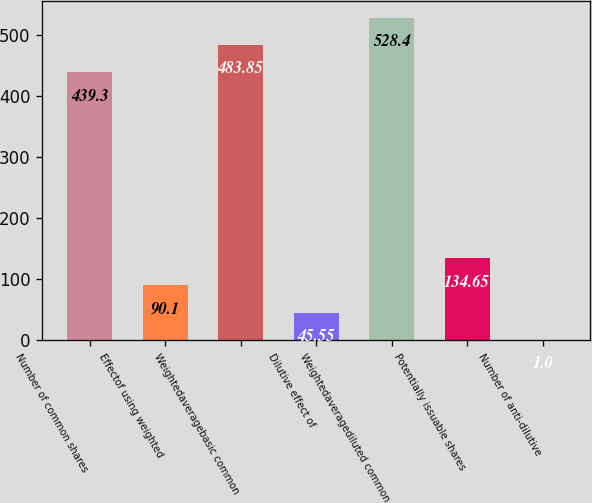Convert chart to OTSL. <chart><loc_0><loc_0><loc_500><loc_500><bar_chart><fcel>Number of common shares<fcel>Effectof using weighted<fcel>Weightedaveragebasic common<fcel>Dilutive effect of<fcel>Weightedaveragediluted common<fcel>Potentially issuable shares<fcel>Number of anti-dilutive<nl><fcel>439.3<fcel>90.1<fcel>483.85<fcel>45.55<fcel>528.4<fcel>134.65<fcel>1<nl></chart> 